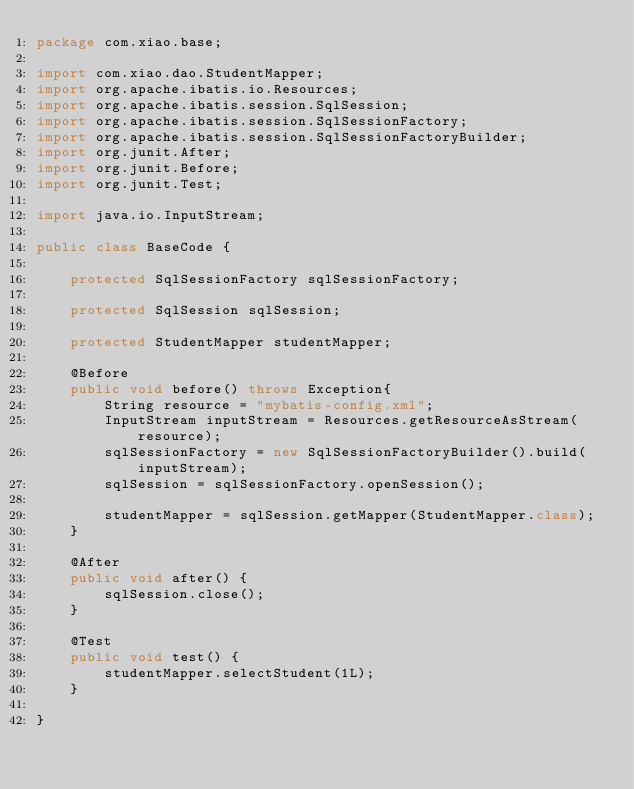Convert code to text. <code><loc_0><loc_0><loc_500><loc_500><_Java_>package com.xiao.base;

import com.xiao.dao.StudentMapper;
import org.apache.ibatis.io.Resources;
import org.apache.ibatis.session.SqlSession;
import org.apache.ibatis.session.SqlSessionFactory;
import org.apache.ibatis.session.SqlSessionFactoryBuilder;
import org.junit.After;
import org.junit.Before;
import org.junit.Test;

import java.io.InputStream;

public class BaseCode {

    protected SqlSessionFactory sqlSessionFactory;

    protected SqlSession sqlSession;

    protected StudentMapper studentMapper;

    @Before
    public void before() throws Exception{
        String resource = "mybatis-config.xml";
        InputStream inputStream = Resources.getResourceAsStream(resource);
        sqlSessionFactory = new SqlSessionFactoryBuilder().build(inputStream);
        sqlSession = sqlSessionFactory.openSession();

        studentMapper = sqlSession.getMapper(StudentMapper.class);
    }

    @After
    public void after() {
        sqlSession.close();
    }

    @Test
    public void test() {
        studentMapper.selectStudent(1L);
    }

}
</code> 